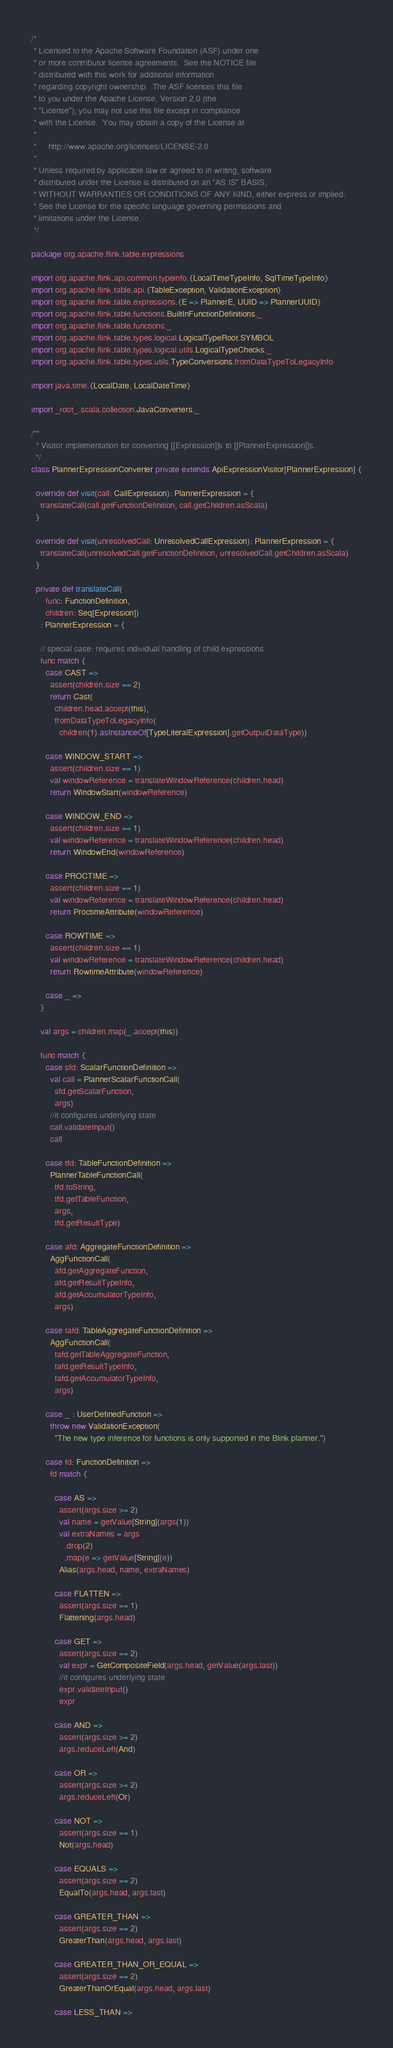Convert code to text. <code><loc_0><loc_0><loc_500><loc_500><_Scala_>/*
 * Licensed to the Apache Software Foundation (ASF) under one
 * or more contributor license agreements.  See the NOTICE file
 * distributed with this work for additional information
 * regarding copyright ownership.  The ASF licenses this file
 * to you under the Apache License, Version 2.0 (the
 * "License"); you may not use this file except in compliance
 * with the License.  You may obtain a copy of the License at
 *
 *     http://www.apache.org/licenses/LICENSE-2.0
 *
 * Unless required by applicable law or agreed to in writing, software
 * distributed under the License is distributed on an "AS IS" BASIS,
 * WITHOUT WARRANTIES OR CONDITIONS OF ANY KIND, either express or implied.
 * See the License for the specific language governing permissions and
 * limitations under the License.
 */

package org.apache.flink.table.expressions

import org.apache.flink.api.common.typeinfo.{LocalTimeTypeInfo, SqlTimeTypeInfo}
import org.apache.flink.table.api.{TableException, ValidationException}
import org.apache.flink.table.expressions.{E => PlannerE, UUID => PlannerUUID}
import org.apache.flink.table.functions.BuiltInFunctionDefinitions._
import org.apache.flink.table.functions._
import org.apache.flink.table.types.logical.LogicalTypeRoot.SYMBOL
import org.apache.flink.table.types.logical.utils.LogicalTypeChecks._
import org.apache.flink.table.types.utils.TypeConversions.fromDataTypeToLegacyInfo

import java.time.{LocalDate, LocalDateTime}

import _root_.scala.collection.JavaConverters._

/**
  * Visitor implementation for converting [[Expression]]s to [[PlannerExpression]]s.
  */
class PlannerExpressionConverter private extends ApiExpressionVisitor[PlannerExpression] {

  override def visit(call: CallExpression): PlannerExpression = {
    translateCall(call.getFunctionDefinition, call.getChildren.asScala)
  }

  override def visit(unresolvedCall: UnresolvedCallExpression): PlannerExpression = {
    translateCall(unresolvedCall.getFunctionDefinition, unresolvedCall.getChildren.asScala)
  }

  private def translateCall(
      func: FunctionDefinition,
      children: Seq[Expression])
    : PlannerExpression = {

    // special case: requires individual handling of child expressions
    func match {
      case CAST =>
        assert(children.size == 2)
        return Cast(
          children.head.accept(this),
          fromDataTypeToLegacyInfo(
            children(1).asInstanceOf[TypeLiteralExpression].getOutputDataType))

      case WINDOW_START =>
        assert(children.size == 1)
        val windowReference = translateWindowReference(children.head)
        return WindowStart(windowReference)

      case WINDOW_END =>
        assert(children.size == 1)
        val windowReference = translateWindowReference(children.head)
        return WindowEnd(windowReference)

      case PROCTIME =>
        assert(children.size == 1)
        val windowReference = translateWindowReference(children.head)
        return ProctimeAttribute(windowReference)

      case ROWTIME =>
        assert(children.size == 1)
        val windowReference = translateWindowReference(children.head)
        return RowtimeAttribute(windowReference)

      case _ =>
    }

    val args = children.map(_.accept(this))

    func match {
      case sfd: ScalarFunctionDefinition =>
        val call = PlannerScalarFunctionCall(
          sfd.getScalarFunction,
          args)
        //it configures underlying state
        call.validateInput()
        call

      case tfd: TableFunctionDefinition =>
        PlannerTableFunctionCall(
          tfd.toString,
          tfd.getTableFunction,
          args,
          tfd.getResultType)

      case afd: AggregateFunctionDefinition =>
        AggFunctionCall(
          afd.getAggregateFunction,
          afd.getResultTypeInfo,
          afd.getAccumulatorTypeInfo,
          args)

      case tafd: TableAggregateFunctionDefinition =>
        AggFunctionCall(
          tafd.getTableAggregateFunction,
          tafd.getResultTypeInfo,
          tafd.getAccumulatorTypeInfo,
          args)

      case _ : UserDefinedFunction =>
        throw new ValidationException(
          "The new type inference for functions is only supported in the Blink planner.")

      case fd: FunctionDefinition =>
        fd match {

          case AS =>
            assert(args.size >= 2)
            val name = getValue[String](args(1))
            val extraNames = args
              .drop(2)
              .map(e => getValue[String](e))
            Alias(args.head, name, extraNames)

          case FLATTEN =>
            assert(args.size == 1)
            Flattening(args.head)

          case GET =>
            assert(args.size == 2)
            val expr = GetCompositeField(args.head, getValue(args.last))
            //it configures underlying state
            expr.validateInput()
            expr

          case AND =>
            assert(args.size >= 2)
            args.reduceLeft(And)

          case OR =>
            assert(args.size >= 2)
            args.reduceLeft(Or)

          case NOT =>
            assert(args.size == 1)
            Not(args.head)

          case EQUALS =>
            assert(args.size == 2)
            EqualTo(args.head, args.last)

          case GREATER_THAN =>
            assert(args.size == 2)
            GreaterThan(args.head, args.last)

          case GREATER_THAN_OR_EQUAL =>
            assert(args.size == 2)
            GreaterThanOrEqual(args.head, args.last)

          case LESS_THAN =></code> 